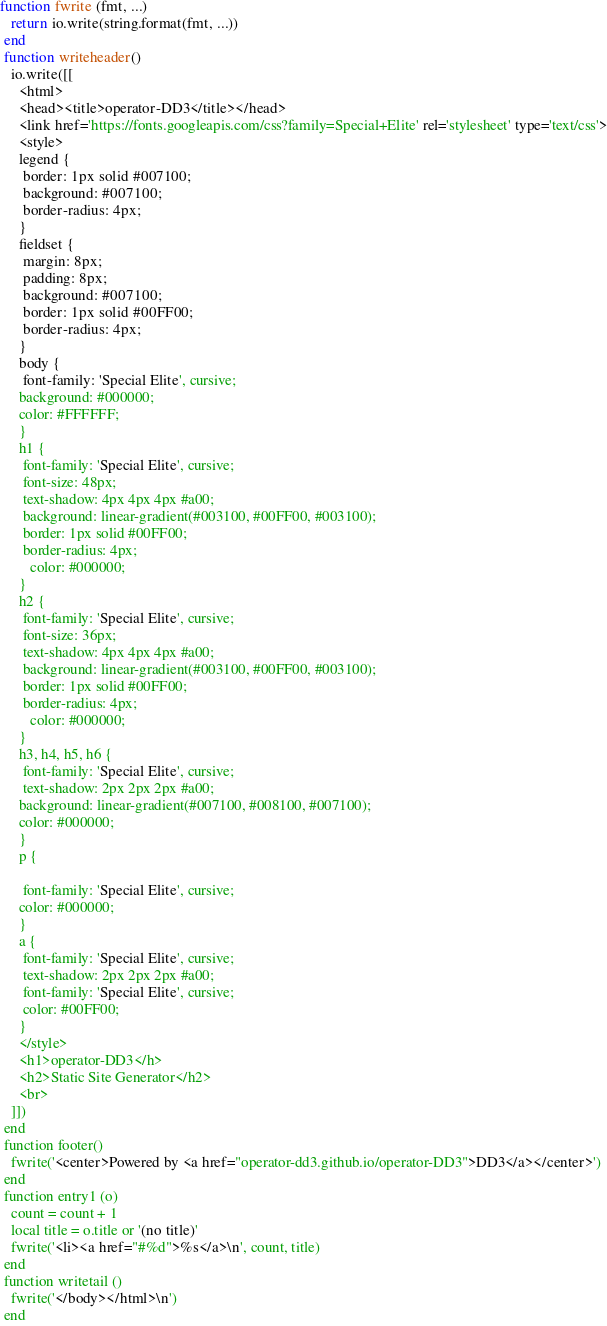<code> <loc_0><loc_0><loc_500><loc_500><_Lua_>function fwrite (fmt, ...) 
   return io.write(string.format(fmt, ...)) 
 end 
 function writeheader() 
   io.write([[ 
     <html> 
     <head><title>operator-DD3</title></head> 
     <link href='https://fonts.googleapis.com/css?family=Special+Elite' rel='stylesheet' type='text/css'>
     <style>
     legend {
      border: 1px solid #007100;
      background: #007100;
      border-radius: 4px;
     }
     fieldset {
      margin: 8px;
      padding: 8px;
      background: #007100;
      border: 1px solid #00FF00;
      border-radius: 4px;
     }
     body {
      font-family: 'Special Elite', cursive;
     background: #000000;
     color: #FFFFFF;
     }
     h1 {
      font-family: 'Special Elite', cursive;
      font-size: 48px;
      text-shadow: 4px 4px 4px #a00;
      background: linear-gradient(#003100, #00FF00, #003100);
      border: 1px solid #00FF00;
      border-radius: 4px;
        color: #000000;
     }
     h2 {
      font-family: 'Special Elite', cursive;
      font-size: 36px;
      text-shadow: 4px 4px 4px #a00;
      background: linear-gradient(#003100, #00FF00, #003100);
      border: 1px solid #00FF00;
      border-radius: 4px;
        color: #000000;
     }
     h3, h4, h5, h6 {
      font-family: 'Special Elite', cursive;
      text-shadow: 2px 2px 2px #a00;
     background: linear-gradient(#007100, #008100, #007100);
     color: #000000;
     }
     p {
     
      font-family: 'Special Elite', cursive;
     color: #000000;
     }
     a {
      font-family: 'Special Elite', cursive;
      text-shadow: 2px 2px 2px #a00;
      font-family: 'Special Elite', cursive;
      color: #00FF00;
     }
     </style>
     <h1>operator-DD3</h>
     <h2>Static Site Generator</h2>
     <br> 
   ]]) 
 end 
 function footer()
   fwrite('<center>Powered by <a href="operator-dd3.github.io/operator-DD3">DD3</a></center>')
 end
 function entry1 (o) 
   count = count + 1 
   local title = o.title or '(no title)' 
   fwrite('<li><a href="#%d">%s</a>\n', count, title) 
 end 
 function writetail () 
   fwrite('</body></html>\n') 
 end </code> 